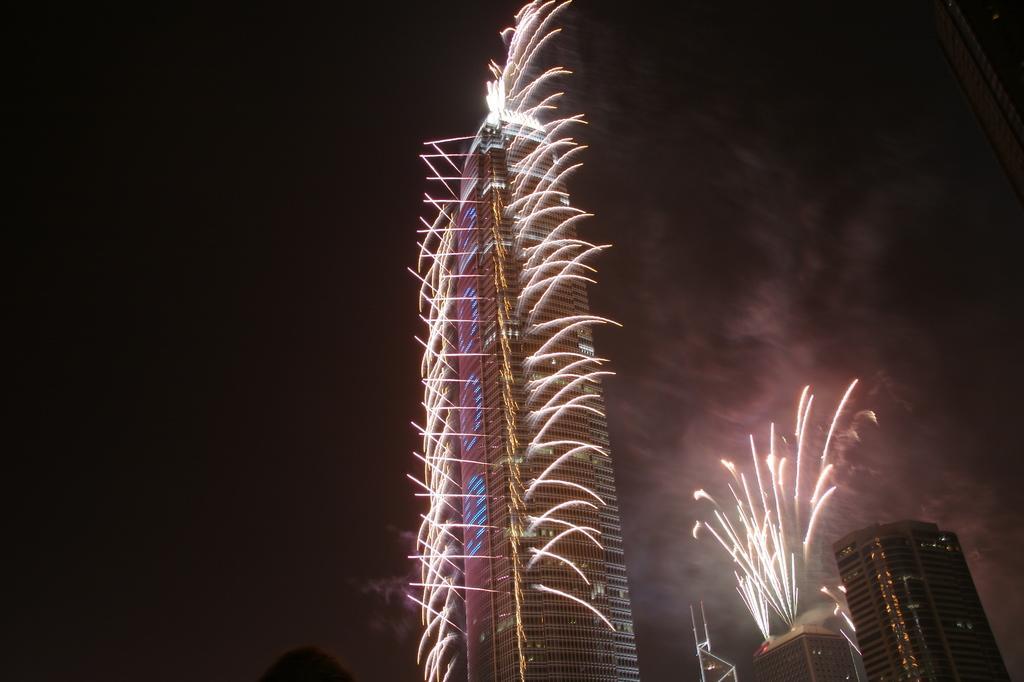In one or two sentences, can you explain what this image depicts? In this image there are buildings and there are fire crackers which are visible. 